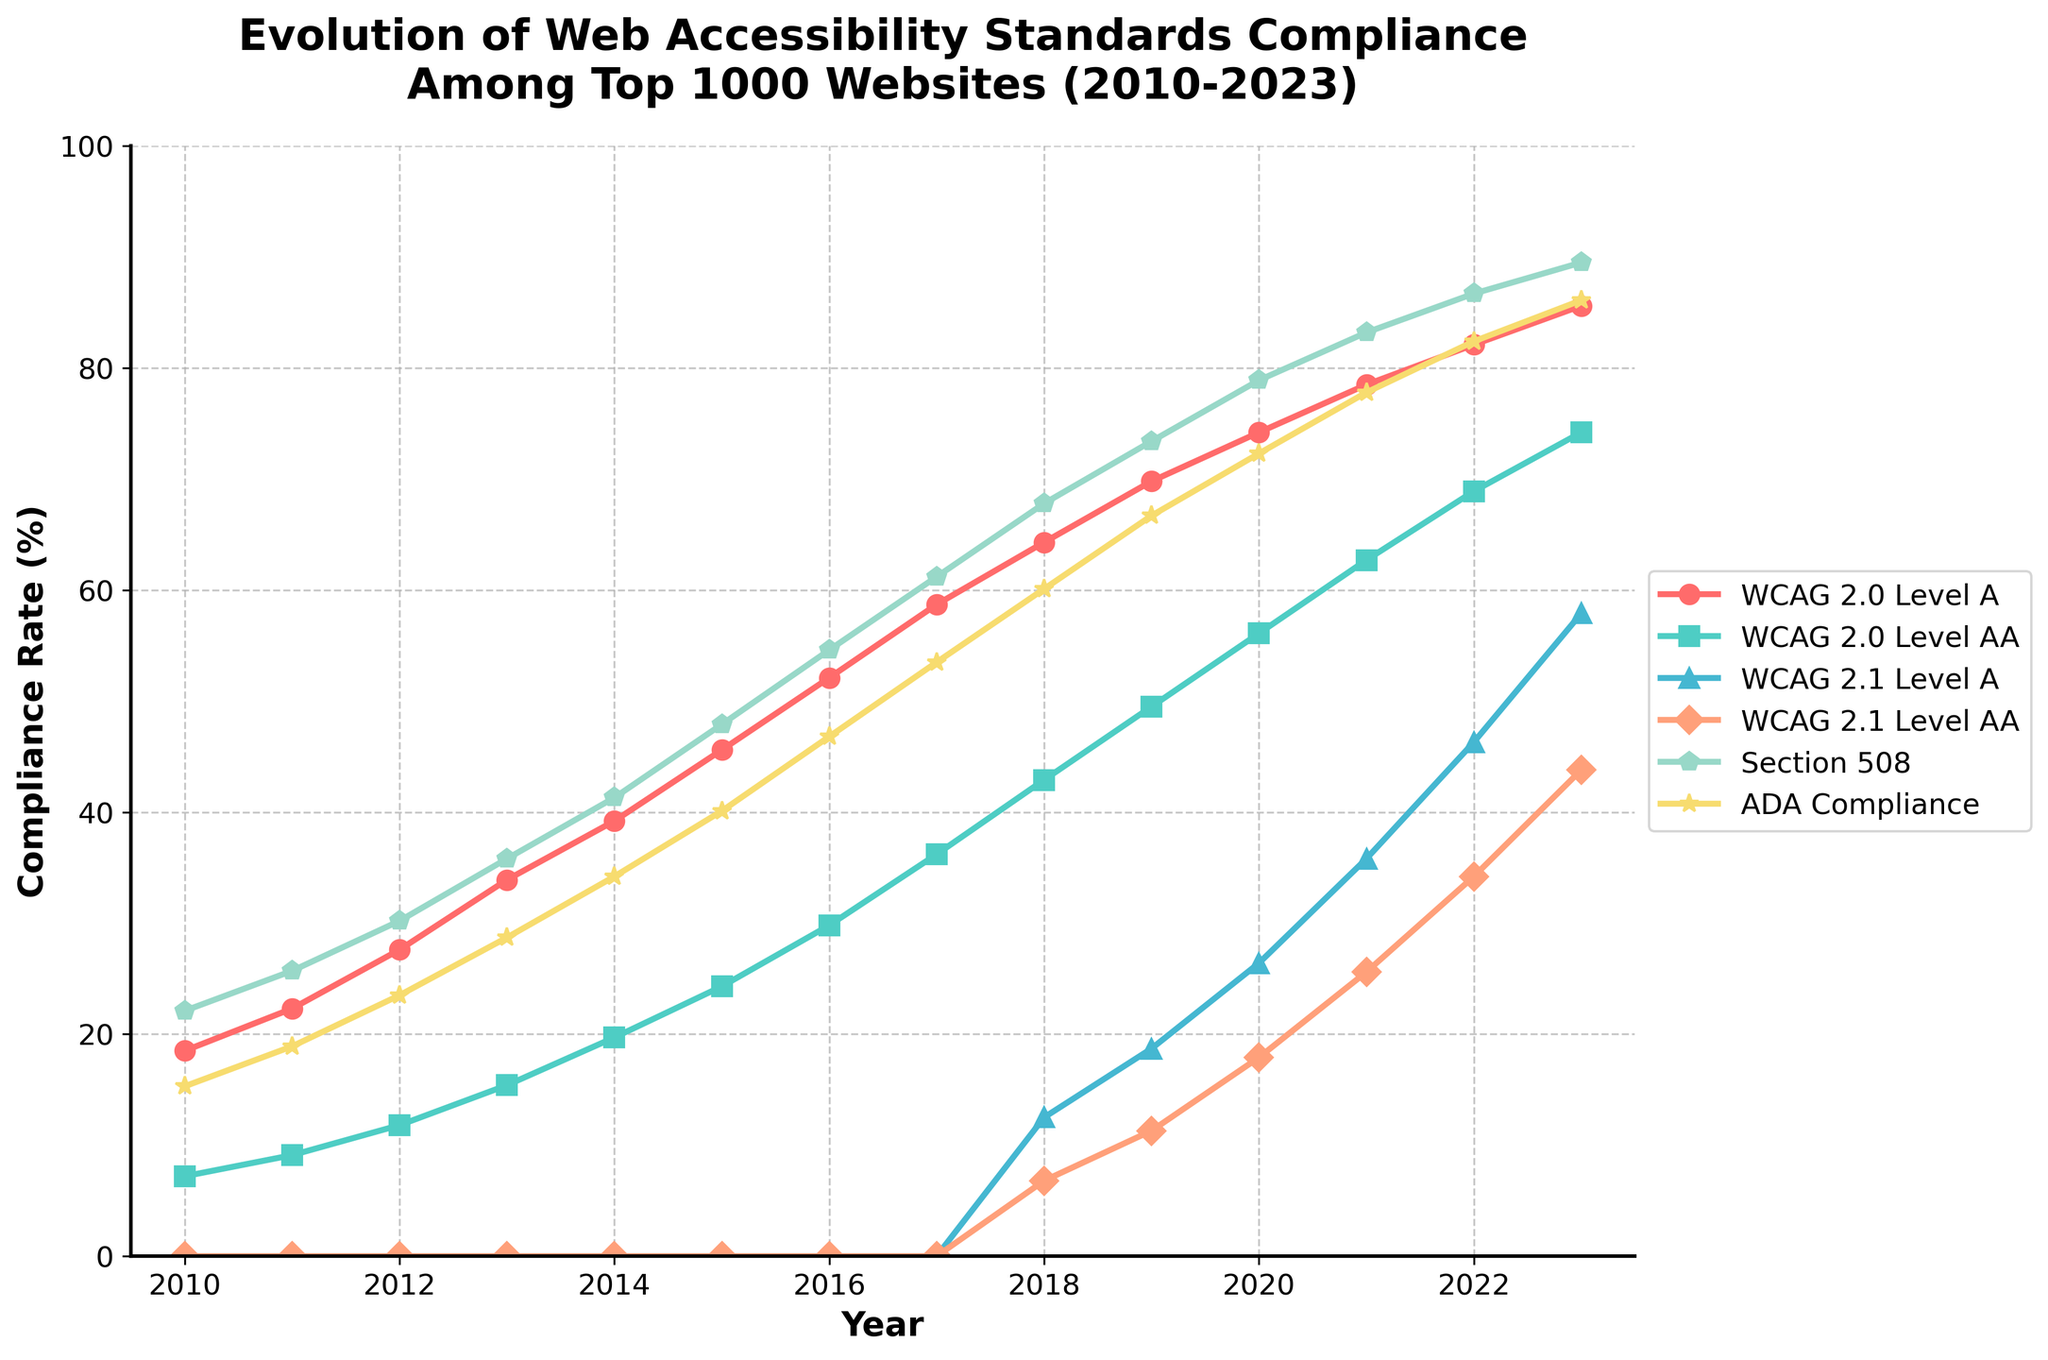What trend do you observe for WCAG 2.0 Level A compliance rate over the years from 2010 to 2023? The compliance rate for WCAG 2.0 Level A shows a continuous increase from 18.5% in 2010 to 85.6% in 2023. This indicates a significant improvement in adherence to this standard over time.
Answer: Continuous increase Which standard has the lowest compliance rate in 2018? To determine this, we need to find the standard with the smallest value in 2018. For 2018, the compliance rates are WCAG 2.0 Level A (64.3%), WCAG 2.0 Level AA (42.9%), WCAG 2.1 Level A (12.5%), WCAG 2.1 Level AA (6.8%), Section 508 (67.8%), ADA Compliance (60.1%). The lowest is WCAG 2.1 Level AA with 6.8%.
Answer: WCAG 2.1 Level AA Compare the growth rate of ADA Compliance from 2021 to 2023 with the growth rate of Section 508 over the same period. The ADA Compliance rate increased from 77.8% in 2021 to 86.1% in 2023, which is an increase of 86.1 - 77.8 = 8.3%. The Section 508 rate increased from 83.2% in 2021 to 89.5% in 2023, which is an increase of 89.5 - 83.2 = 6.3%. Comparatively, ADA Compliance had a higher growth rate (8.3%) than Section 508 (6.3%).
Answer: ADA Compliance What is the average compliance rate of WCAG 2.1 Level A between 2018 and 2023? To find the average, sum the compliance rates for WCAG 2.1 Level A from 2018 to 2023 and then divide by the number of years. The values are 12.5, 18.7, 26.4, 35.8, 46.3, and 57.9. Sum = 12.5 + 18.7 + 26.4 + 35.8 + 46.3 + 57.9 = 197.6. Average = 197.6 / 6 = 32.93.
Answer: 32.93 Which year saw the biggest increase in WCAG 2.0 Level AA compliance rate compared to the previous year? We need to compare the year-over-year differences for WCAG 2.0 Level AA. The increases are: 
2011: 9.1 - 7.2 = 1.9 
2012: 11.8 - 9.1 = 2.7 
2013: 15.4 - 11.8 = 3.6 
2014: 19.7 - 15.4 = 4.3 
2015: 24.3 - 19.7 = 4.6 
2016: 29.8 - 24.3 = 5.5 
2017: 36.2 - 29.8 = 6.4 
2018: 42.9 - 36.2 = 6.7 
2019: 49.5 - 42.9 = 6.6 
2020: 56.1 - 49.5 = 6.6 
2021: 62.7 - 56.1 = 6.6 
2022: 68.9 - 62.7 = 6.2 
2023: 74.2 - 68.9 = 5.3.
2018 had the largest increase of 6.7%.
Answer: 2018 In what year did WCAG 2.1 Level A compliance rate begin to be reported? Observing the plotted lines and dots, WCAG 2.1 Level A compliance rates start to appear in 2018, indicated by the first non-zero data point.
Answer: 2018 For the year 2020, comparing the compliance rates of WCAG 2.1 Level A and WCAG 2.1 Level AA, by how much does the WCAG 2.1 Level A compliance rate exceed WCAG 2.1 Level AA? For 2020, the compliance rates are WCAG 2.1 Level A (26.4%) and WCAG 2.1 Level AA (17.9%). Difference = 26.4 - 17.9 = 8.5%.
Answer: 8.5% Identify the two standards with the closest compliance rates in 2023 and provide the difference in their rates. In 2023, the compliance rates are: WCAG 2.0 Level A (85.6%), WCAG 2.0 Level AA (74.2%), WCAG 2.1 Level A (57.9%), WCAG 2.1 Level AA (43.8%), Section 508 (89.5%), ADA Compliance (86.1%). WCAG 2.0 Level A and ADA Compliance are the closest, with a difference of 86.1 - 85.6 = 0.5%.
Answer: WCAG 2.0 Level A and ADA Compliance, 0.5% 